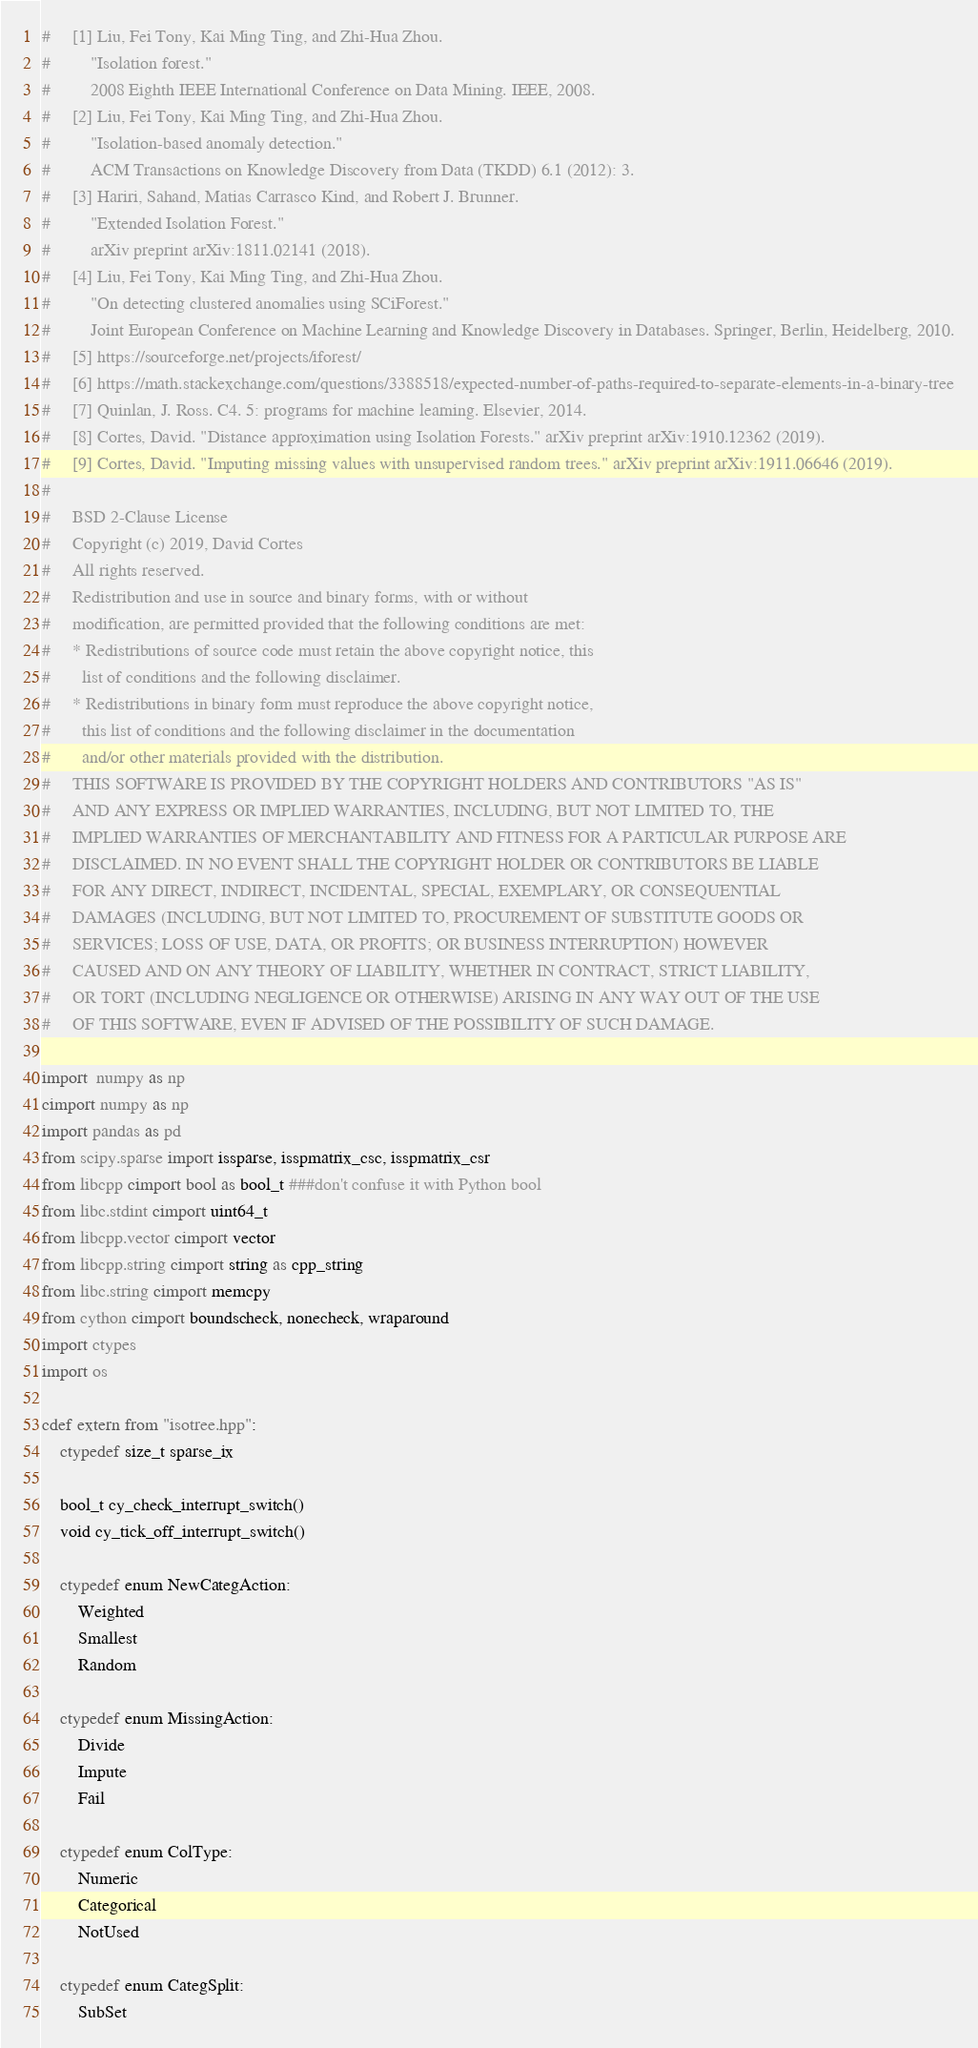<code> <loc_0><loc_0><loc_500><loc_500><_Cython_>#     [1] Liu, Fei Tony, Kai Ming Ting, and Zhi-Hua Zhou.
#         "Isolation forest."
#         2008 Eighth IEEE International Conference on Data Mining. IEEE, 2008.
#     [2] Liu, Fei Tony, Kai Ming Ting, and Zhi-Hua Zhou.
#         "Isolation-based anomaly detection."
#         ACM Transactions on Knowledge Discovery from Data (TKDD) 6.1 (2012): 3.
#     [3] Hariri, Sahand, Matias Carrasco Kind, and Robert J. Brunner.
#         "Extended Isolation Forest."
#         arXiv preprint arXiv:1811.02141 (2018).
#     [4] Liu, Fei Tony, Kai Ming Ting, and Zhi-Hua Zhou.
#         "On detecting clustered anomalies using SCiForest."
#         Joint European Conference on Machine Learning and Knowledge Discovery in Databases. Springer, Berlin, Heidelberg, 2010.
#     [5] https://sourceforge.net/projects/iforest/
#     [6] https://math.stackexchange.com/questions/3388518/expected-number-of-paths-required-to-separate-elements-in-a-binary-tree
#     [7] Quinlan, J. Ross. C4. 5: programs for machine learning. Elsevier, 2014.
#     [8] Cortes, David. "Distance approximation using Isolation Forests." arXiv preprint arXiv:1910.12362 (2019).
#     [9] Cortes, David. "Imputing missing values with unsupervised random trees." arXiv preprint arXiv:1911.06646 (2019).
# 
#     BSD 2-Clause License
#     Copyright (c) 2019, David Cortes
#     All rights reserved.
#     Redistribution and use in source and binary forms, with or without
#     modification, are permitted provided that the following conditions are met:
#     * Redistributions of source code must retain the above copyright notice, this
#       list of conditions and the following disclaimer.
#     * Redistributions in binary form must reproduce the above copyright notice,
#       this list of conditions and the following disclaimer in the documentation
#       and/or other materials provided with the distribution.
#     THIS SOFTWARE IS PROVIDED BY THE COPYRIGHT HOLDERS AND CONTRIBUTORS "AS IS"
#     AND ANY EXPRESS OR IMPLIED WARRANTIES, INCLUDING, BUT NOT LIMITED TO, THE
#     IMPLIED WARRANTIES OF MERCHANTABILITY AND FITNESS FOR A PARTICULAR PURPOSE ARE
#     DISCLAIMED. IN NO EVENT SHALL THE COPYRIGHT HOLDER OR CONTRIBUTORS BE LIABLE
#     FOR ANY DIRECT, INDIRECT, INCIDENTAL, SPECIAL, EXEMPLARY, OR CONSEQUENTIAL
#     DAMAGES (INCLUDING, BUT NOT LIMITED TO, PROCUREMENT OF SUBSTITUTE GOODS OR
#     SERVICES; LOSS OF USE, DATA, OR PROFITS; OR BUSINESS INTERRUPTION) HOWEVER
#     CAUSED AND ON ANY THEORY OF LIABILITY, WHETHER IN CONTRACT, STRICT LIABILITY,
#     OR TORT (INCLUDING NEGLIGENCE OR OTHERWISE) ARISING IN ANY WAY OUT OF THE USE
#     OF THIS SOFTWARE, EVEN IF ADVISED OF THE POSSIBILITY OF SUCH DAMAGE.

import  numpy as np
cimport numpy as np
import pandas as pd
from scipy.sparse import issparse, isspmatrix_csc, isspmatrix_csr
from libcpp cimport bool as bool_t ###don't confuse it with Python bool
from libc.stdint cimport uint64_t
from libcpp.vector cimport vector
from libcpp.string cimport string as cpp_string
from libc.string cimport memcpy
from cython cimport boundscheck, nonecheck, wraparound
import ctypes
import os

cdef extern from "isotree.hpp":
    ctypedef size_t sparse_ix

    bool_t cy_check_interrupt_switch()
    void cy_tick_off_interrupt_switch()

    ctypedef enum NewCategAction:
        Weighted
        Smallest
        Random

    ctypedef enum MissingAction:
        Divide
        Impute
        Fail

    ctypedef enum ColType:
        Numeric
        Categorical
        NotUsed

    ctypedef enum CategSplit:
        SubSet</code> 